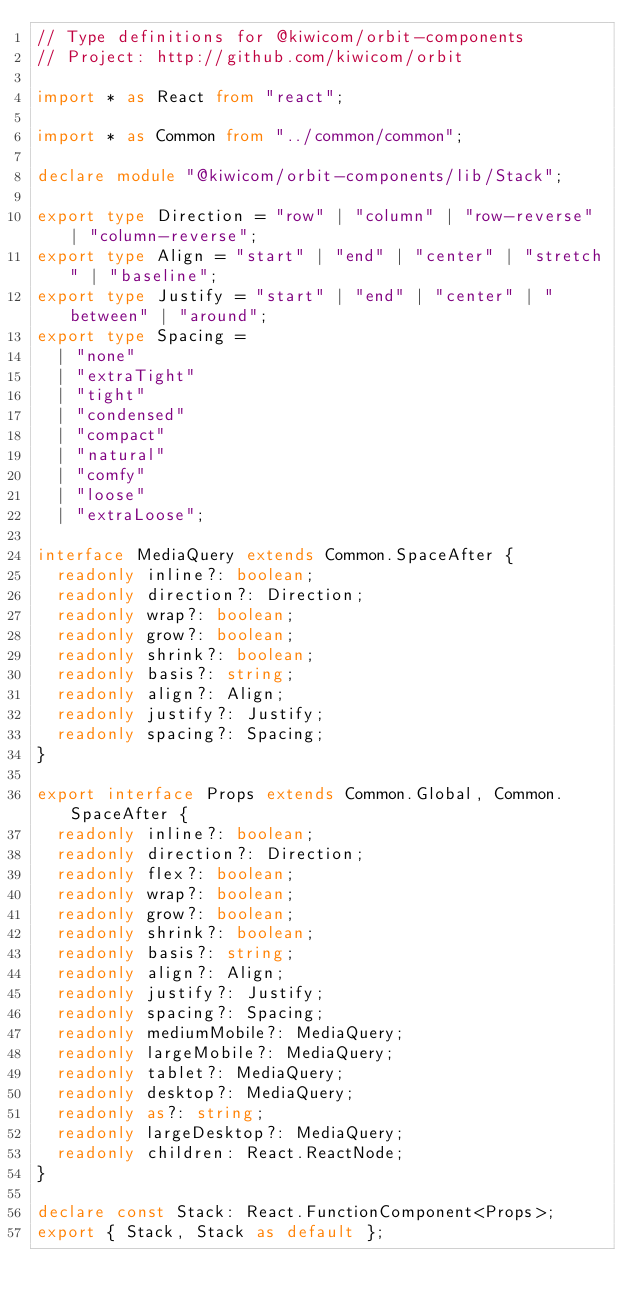<code> <loc_0><loc_0><loc_500><loc_500><_TypeScript_>// Type definitions for @kiwicom/orbit-components
// Project: http://github.com/kiwicom/orbit

import * as React from "react";

import * as Common from "../common/common";

declare module "@kiwicom/orbit-components/lib/Stack";

export type Direction = "row" | "column" | "row-reverse" | "column-reverse";
export type Align = "start" | "end" | "center" | "stretch" | "baseline";
export type Justify = "start" | "end" | "center" | "between" | "around";
export type Spacing =
  | "none"
  | "extraTight"
  | "tight"
  | "condensed"
  | "compact"
  | "natural"
  | "comfy"
  | "loose"
  | "extraLoose";

interface MediaQuery extends Common.SpaceAfter {
  readonly inline?: boolean;
  readonly direction?: Direction;
  readonly wrap?: boolean;
  readonly grow?: boolean;
  readonly shrink?: boolean;
  readonly basis?: string;
  readonly align?: Align;
  readonly justify?: Justify;
  readonly spacing?: Spacing;
}

export interface Props extends Common.Global, Common.SpaceAfter {
  readonly inline?: boolean;
  readonly direction?: Direction;
  readonly flex?: boolean;
  readonly wrap?: boolean;
  readonly grow?: boolean;
  readonly shrink?: boolean;
  readonly basis?: string;
  readonly align?: Align;
  readonly justify?: Justify;
  readonly spacing?: Spacing;
  readonly mediumMobile?: MediaQuery;
  readonly largeMobile?: MediaQuery;
  readonly tablet?: MediaQuery;
  readonly desktop?: MediaQuery;
  readonly as?: string;
  readonly largeDesktop?: MediaQuery;
  readonly children: React.ReactNode;
}

declare const Stack: React.FunctionComponent<Props>;
export { Stack, Stack as default };
</code> 